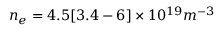<formula> <loc_0><loc_0><loc_500><loc_500>n _ { e } = 4 . 5 [ 3 . 4 - 6 ] \times 1 0 ^ { 1 9 } m ^ { - 3 }</formula> 